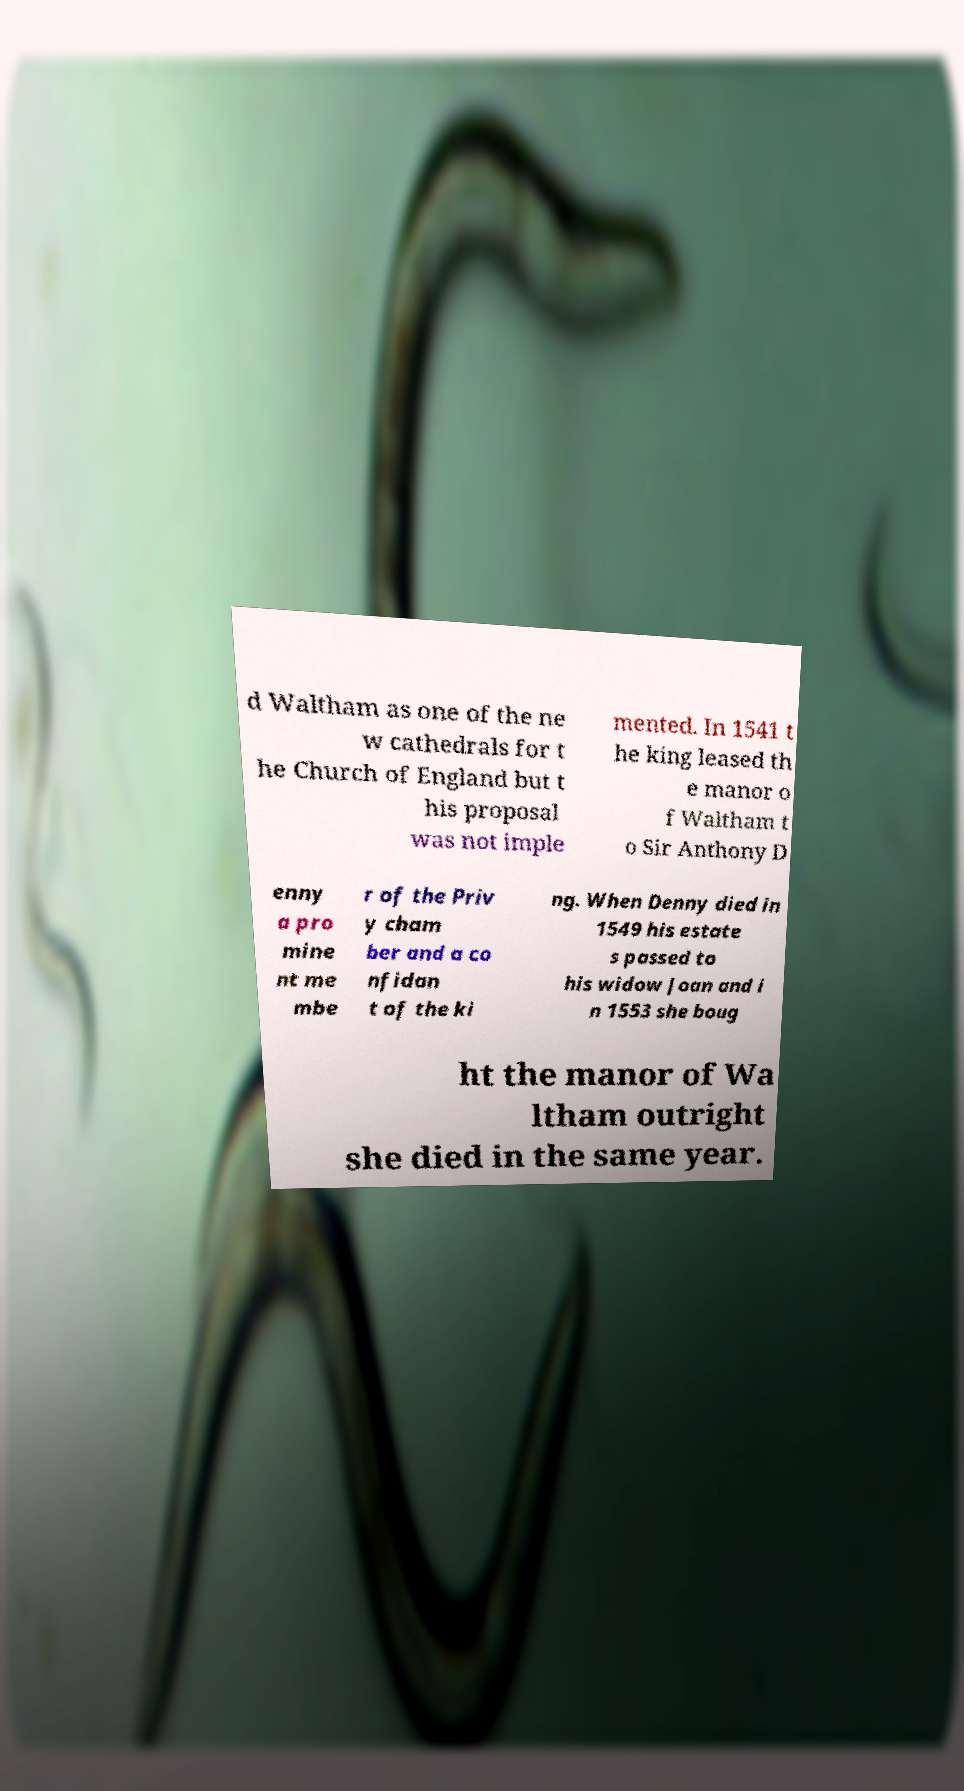I need the written content from this picture converted into text. Can you do that? d Waltham as one of the ne w cathedrals for t he Church of England but t his proposal was not imple mented. In 1541 t he king leased th e manor o f Waltham t o Sir Anthony D enny a pro mine nt me mbe r of the Priv y cham ber and a co nfidan t of the ki ng. When Denny died in 1549 his estate s passed to his widow Joan and i n 1553 she boug ht the manor of Wa ltham outright she died in the same year. 